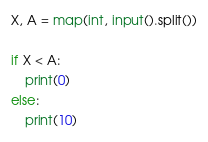<code> <loc_0><loc_0><loc_500><loc_500><_Python_>X, A = map(int, input().split())

if X < A:
    print(0)
else:
    print(10)</code> 